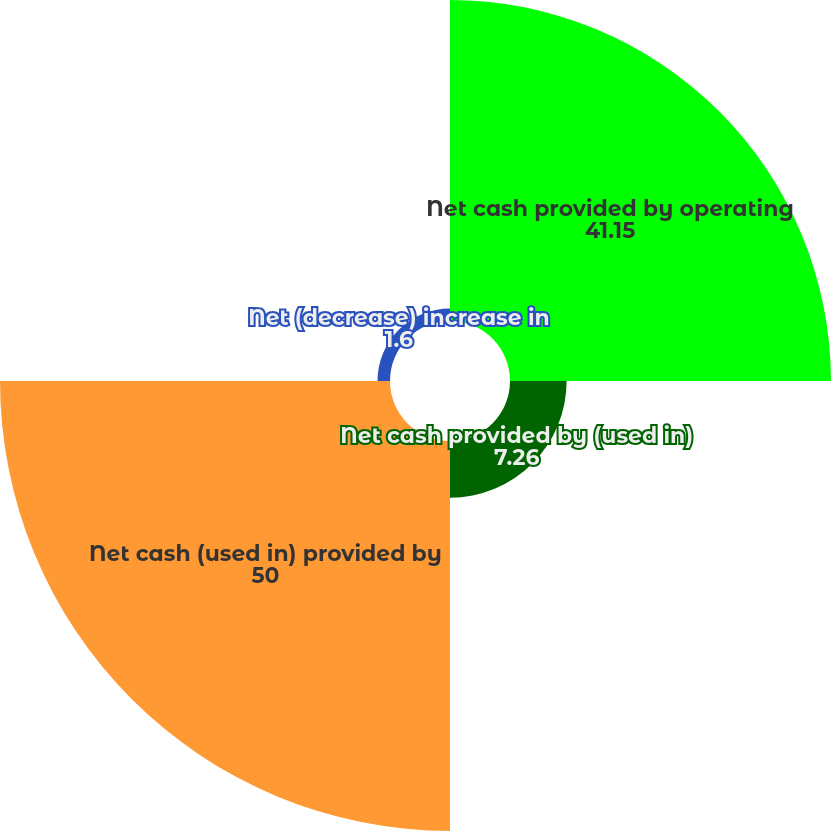Convert chart. <chart><loc_0><loc_0><loc_500><loc_500><pie_chart><fcel>Net cash provided by operating<fcel>Net cash provided by (used in)<fcel>Net cash (used in) provided by<fcel>Net (decrease) increase in<nl><fcel>41.15%<fcel>7.26%<fcel>50.0%<fcel>1.6%<nl></chart> 